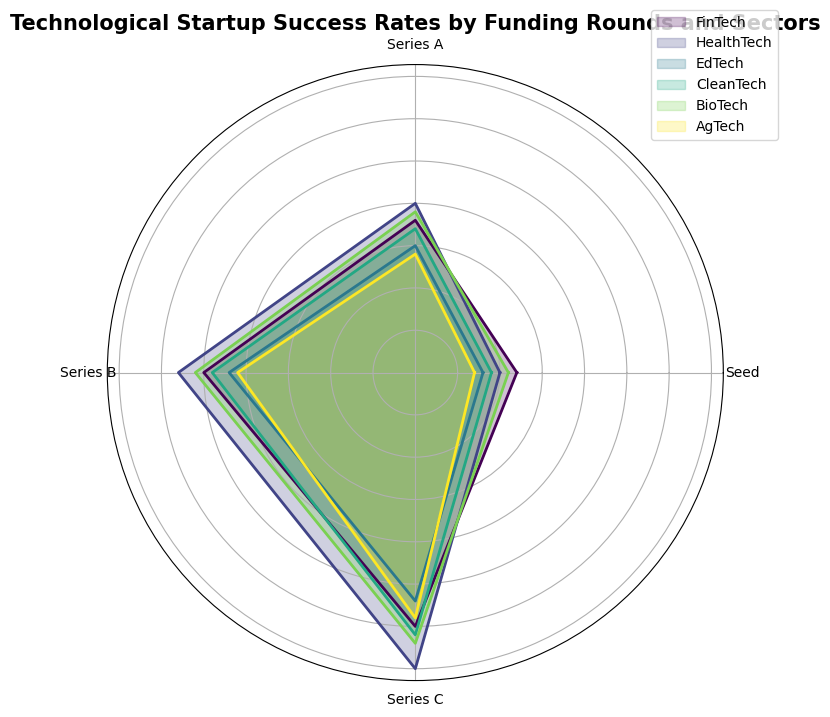Which sector has the highest success rate in the Series C funding round? To determine this, we look at the Series C funding round for each sector and compare their success rates. HealthTech has a success rate of 35%, which is the highest among all sectors.
Answer: HealthTech What is the average success rate for EdTech across all funding rounds? Sum the success rates for EdTech across all funding rounds (Seed, Series A, Series B, Series C): 8 + 15 + 22 + 27 = 72. Then, divide by the number of rounds, which is 4. The average is 72 / 4 = 18.
Answer: 18 Which sector has the smallest difference in success rates between the Seed round and Series C round? Calculate the difference for each sector between the Seed and Series C rounds:
- FinTech: 30 - 12 = 18
- HealthTech: 35 - 10 = 25
- EdTech: 27 - 8 = 19
- CleanTech: 31 - 9 = 22
- BioTech: 32 - 11 = 21
- AgTech: 29 - 7 = 22
FinTech has the smallest difference of 18.
Answer: FinTech How does the success rate of CleanTech in the Series A round compare to BioTech in the same round? Compare the success rates of CleanTech and BioTech in the Series A funding round:
- CleanTech: 17%
- BioTech: 19%
BioTech's success rate is greater than CleanTech's.
Answer: BioTech has a higher success rate What is the total success rate across all funding rounds for FinTech? Sum the success rates for FinTech across all funding rounds: 12 + 18 + 25 + 30 = 85.
Answer: 85 Which sector has the lowest success rate in the Seed funding round? Look at the success rates for the Seed funding round for each sector and find the lowest:
- FinTech: 12%
- HealthTech: 10%
- EdTech: 8%
- CleanTech: 9%
- BioTech: 11%
- AgTech: 7%
AgTech has the lowest success rate of 7%.
Answer: AgTech Which funding round shows the greatest increase in success rate from the Seed round for HealthTech? Calculate the increase from the Seed to each subsequent round for HealthTech:
- Seed to Series A: 20 - 10 = 10
- Seed to Series B: 28 - 10 = 18
- Seed to Series C: 35 - 10 = 25
The greatest increase is from Seed to Series C with an increase of 25%.
Answer: Series C Are the success rates in Series B higher for HealthTech or EdTech? Compare the success rates for HealthTech and EdTech in the Series B funding round:
- HealthTech: 28%
- EdTech: 22%
HealthTech has a higher success rate.
Answer: HealthTech By how much does CleanTech's success rate improve from Series A to Series C? Subtract the success rate of Series A from Series C for CleanTech:
31 - 17 = 14. The improvement is by 14%.
Answer: 14 